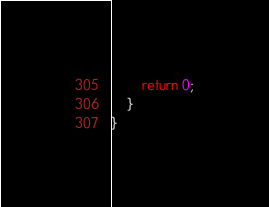Convert code to text. <code><loc_0><loc_0><loc_500><loc_500><_Java_>        return 0;
    }
}
</code> 